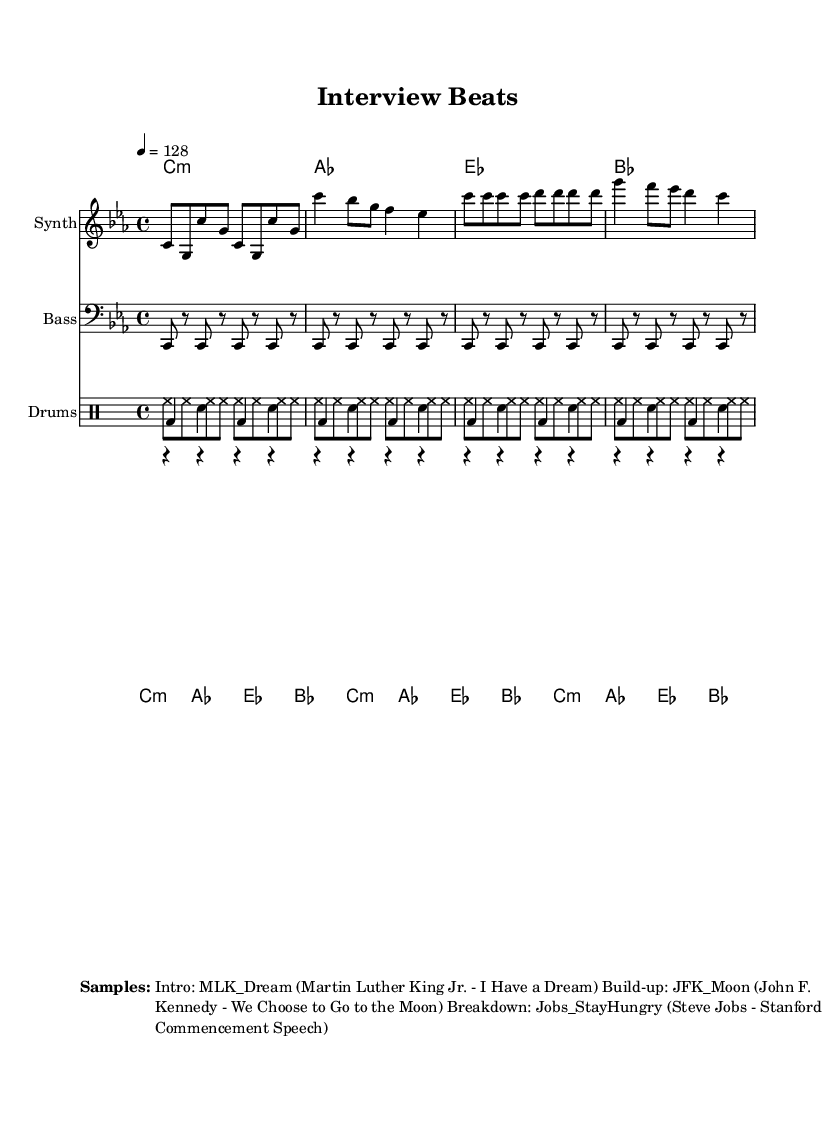What is the key signature of this music? The key signature is C minor, which has three flats: B, E, and A. This can be determined by looking at the key signature symbol placed at the beginning of the staff.
Answer: C minor What is the time signature of this piece? The time signature is 4/4, which is indicated at the beginning of the score. It means there are four beats in a measure, and each quarter note gets one beat.
Answer: 4/4 What is the tempo marking for this composition? The tempo marking is a quarter note equals 128 beats per minute, as noted in the tempo directive at the beginning of the score. This indicates a moderately fast pace for the piece.
Answer: 128 How many measures are in the synthesizer part? The synthesizer part contains 16 measures, which can be counted directly from the notation of the synthesizer staff in the score. Each grouping of notes corresponds to one measure.
Answer: 16 What is the total number of drum voices used in this piece? There are three drum voices indicated: kick drum, hi-hat, and snare drum. This information is displayed in the drum staff section of the score, where each voice is labeled.
Answer: Three Which sample is used in the breakdown section? The sample used in the breakdown section is "Jobs_StayHungry," which is noted in the markup section of the score that provides additional information about the samples included in the music.
Answer: Jobs_StayHungry What chord is repeated in the chord names section? The C minor chord is repeated in the chord names section, indicating that it appears multiple times throughout the composition. This is shown in the chord names part of the score where C minor is listed.
Answer: C minor 